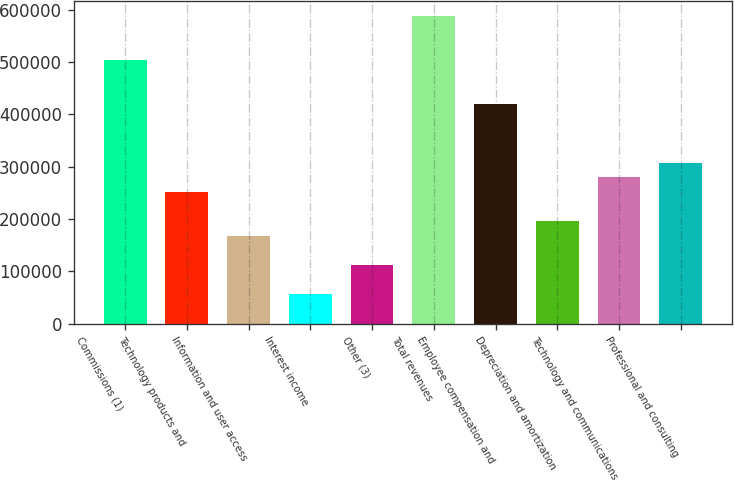<chart> <loc_0><loc_0><loc_500><loc_500><bar_chart><fcel>Commissions (1)<fcel>Technology products and<fcel>Information and user access<fcel>Interest income<fcel>Other (3)<fcel>Total revenues<fcel>Employee compensation and<fcel>Depreciation and amortization<fcel>Technology and communications<fcel>Professional and consulting<nl><fcel>503713<fcel>251857<fcel>167905<fcel>55969.5<fcel>111937<fcel>587664<fcel>419761<fcel>195889<fcel>279841<fcel>307825<nl></chart> 